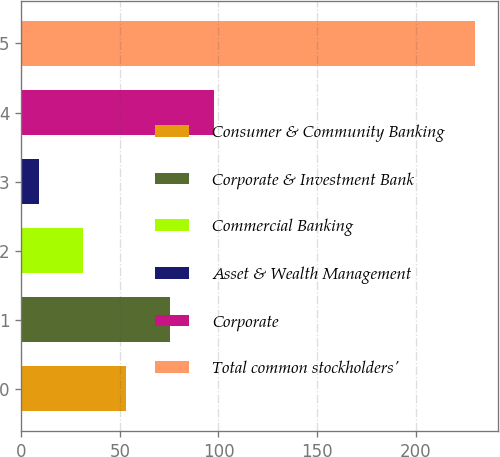<chart> <loc_0><loc_0><loc_500><loc_500><bar_chart><fcel>Consumer & Community Banking<fcel>Corporate & Investment Bank<fcel>Commercial Banking<fcel>Asset & Wealth Management<fcel>Corporate<fcel>Total common stockholders'<nl><fcel>53.28<fcel>75.42<fcel>31.14<fcel>9<fcel>97.56<fcel>230.4<nl></chart> 